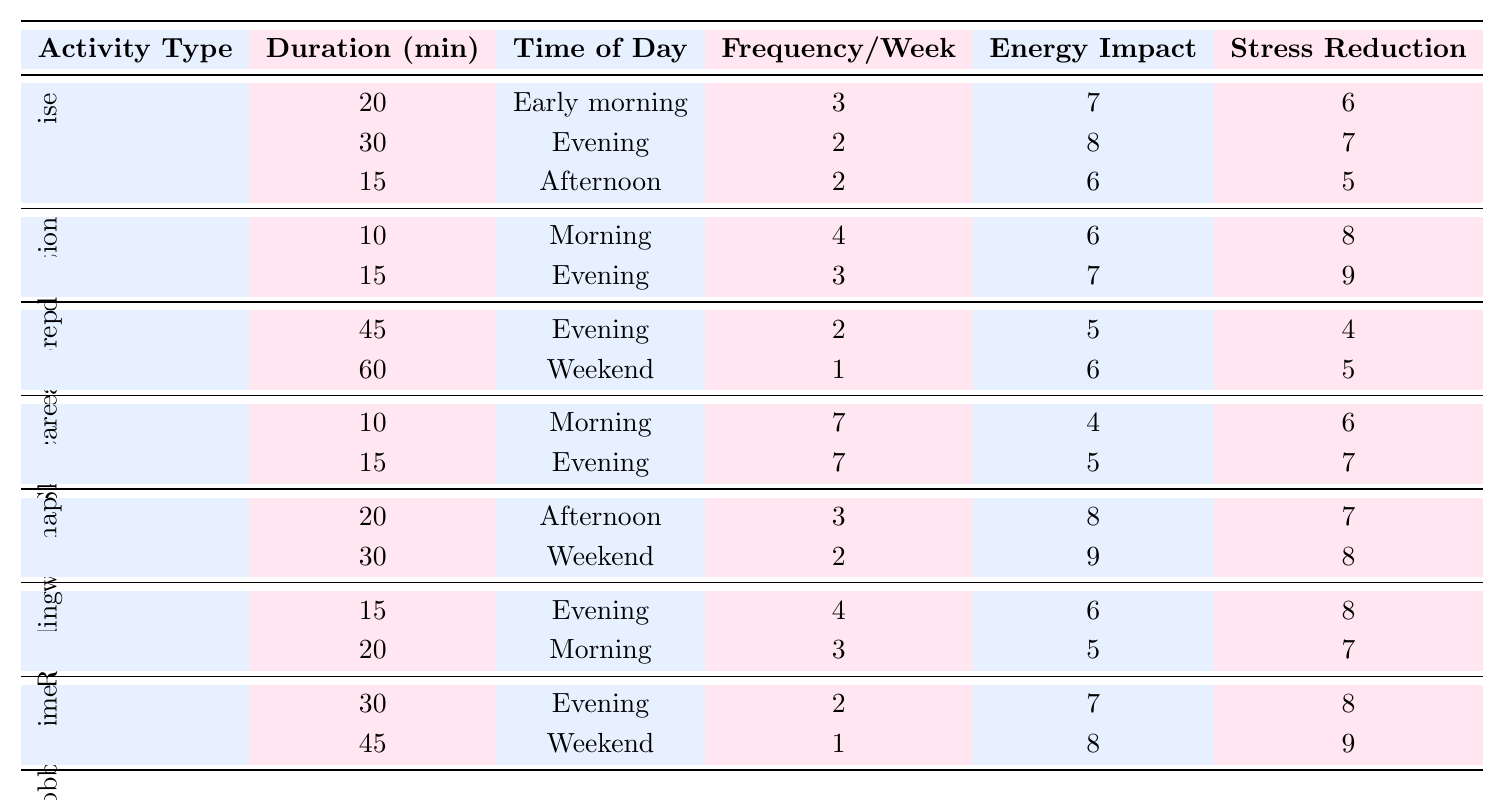What is the duration of the longest exercise session? The longest exercise session has a duration of 30 minutes, which is listed under the evening time slot.
Answer: 30 How many times a week do parents meditate in the morning? Parents meditate in the morning 4 times a week, as indicated in the table.
Answer: 4 What is the total duration of hobby time per week? Hobby time consists of two sessions: 30 minutes in the evening (2 times a week) and 45 minutes on the weekend (1 time). Thus, the total duration is (30*2) + (45*1) = 60 + 45 = 105 minutes.
Answer: 105 Which self-care activity has the highest stress reduction score? The highest stress reduction score of 9 is assigned to meditation (15 minutes in the evening), hobby time (45 minutes on the weekend), and power nap (30 minutes on the weekend).
Answer: Meditation, Hobby time, Power nap How many activity types are listed in the table? There are 6 unique activity types in the table: Exercise, Meditation, Meal prep, Skincare routine, Power nap, Reading, and Hobby time.
Answer: 6 Is the energy impact of reading in the morning higher than that of meal prep in the evening? Reading in the morning has an energy impact of 5, while meal prep in the evening has an energy impact of 4. Therefore, reading has a higher energy impact.
Answer: Yes What is the average duration of all self-care activities listed in the table? To find the average duration, sum all durations: 20 + 30 + 15 + 10 + 15 + 45 + 60 + 10 + 15 + 20 + 30 + 15 + 20 + 30 + 45 =  525 minutes. Dividing by the total activities (15), the average duration is 525 / 15 = 35 minutes.
Answer: 35 How many activities are scheduled for the evening? There are 6 activities scheduled for the evening: Exercise (30 min), Meditation (15 min), Meal prep (45 min), Skincare routine (15 min), Power nap (20 min), Reading (15 min), and Hobby time (30 min). This gives a total of 6 evening activities.
Answer: 6 Which activity has the highest frequency of occurrence during the week? The skincare routine has the highest frequency, occurring 7 times a week, scheduled for the morning and evening.
Answer: Skincare routine What is the difference in stress reduction scores between the power nap and reading? The stress reduction score for the power nap (30 minutes on the weekend) is 8, while for reading (15 minutes in the evening) it is 8. The difference is 8 - 8 = 0.
Answer: 0 